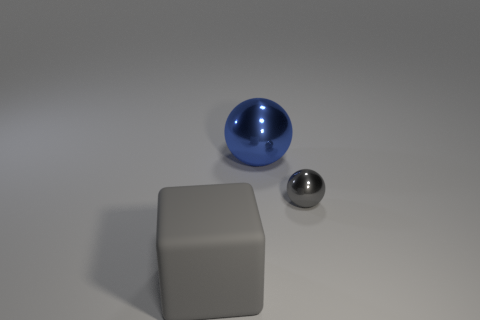Subtract 1 balls. How many balls are left? 1 Subtract all blue balls. How many balls are left? 1 Subtract all cyan blocks. How many cyan balls are left? 0 Add 3 big gray shiny cylinders. How many objects exist? 6 Subtract all balls. How many objects are left? 1 Subtract all green cubes. Subtract all yellow balls. How many cubes are left? 1 Subtract all tiny metal objects. Subtract all small metal things. How many objects are left? 1 Add 2 large spheres. How many large spheres are left? 3 Add 3 spheres. How many spheres exist? 5 Subtract 0 purple blocks. How many objects are left? 3 